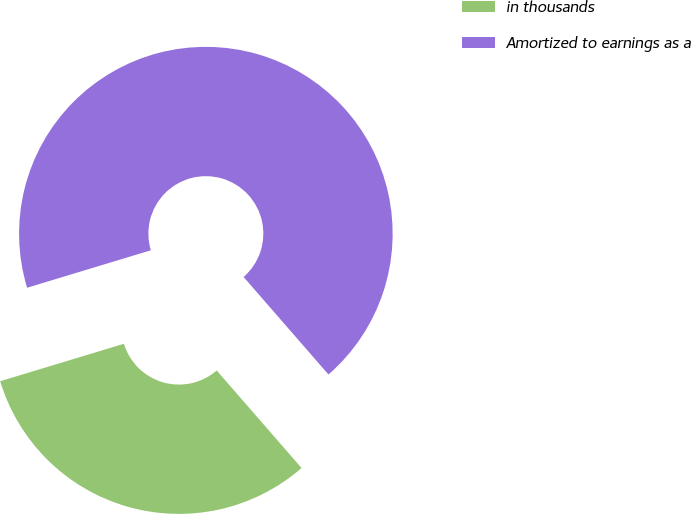<chart> <loc_0><loc_0><loc_500><loc_500><pie_chart><fcel>in thousands<fcel>Amortized to earnings as a<nl><fcel>31.72%<fcel>68.28%<nl></chart> 